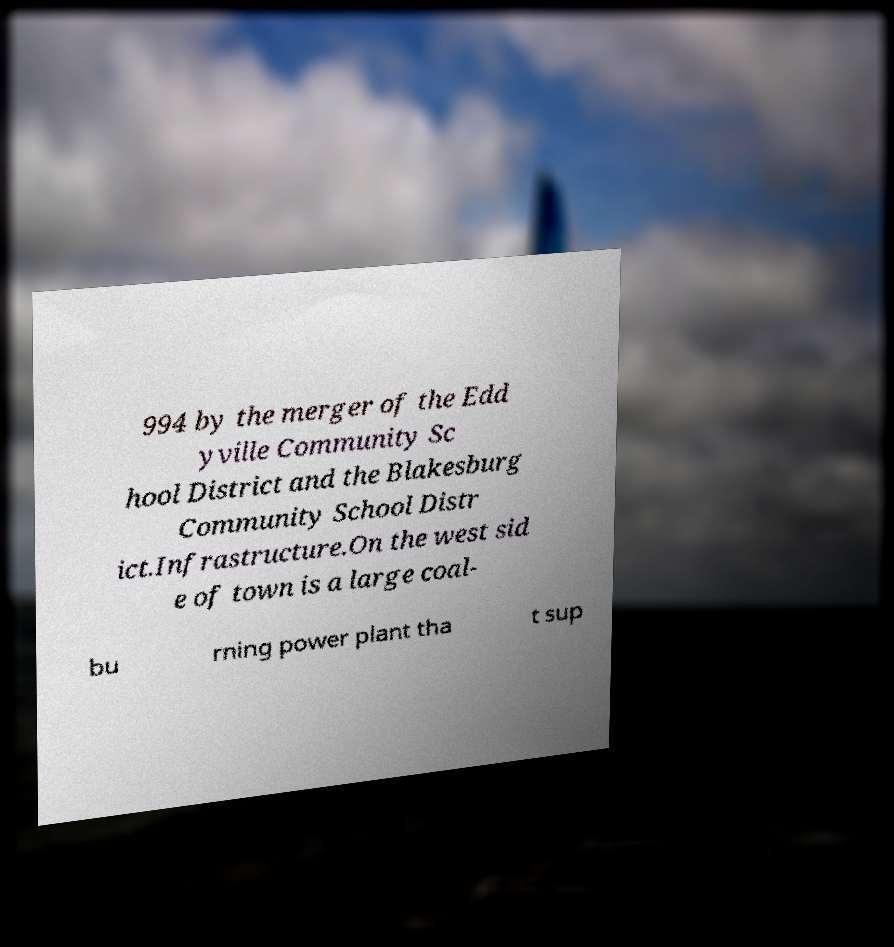There's text embedded in this image that I need extracted. Can you transcribe it verbatim? 994 by the merger of the Edd yville Community Sc hool District and the Blakesburg Community School Distr ict.Infrastructure.On the west sid e of town is a large coal- bu rning power plant tha t sup 